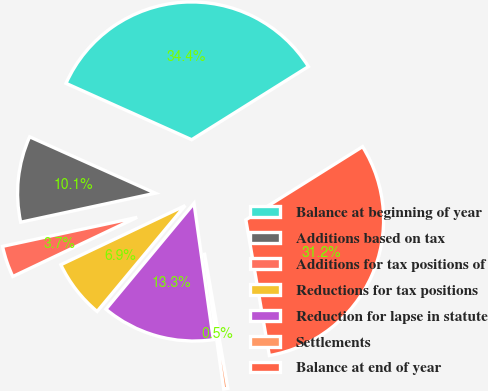Convert chart to OTSL. <chart><loc_0><loc_0><loc_500><loc_500><pie_chart><fcel>Balance at beginning of year<fcel>Additions based on tax<fcel>Additions for tax positions of<fcel>Reductions for tax positions<fcel>Reduction for lapse in statute<fcel>Settlements<fcel>Balance at end of year<nl><fcel>34.38%<fcel>10.09%<fcel>3.69%<fcel>6.89%<fcel>13.28%<fcel>0.49%<fcel>31.18%<nl></chart> 